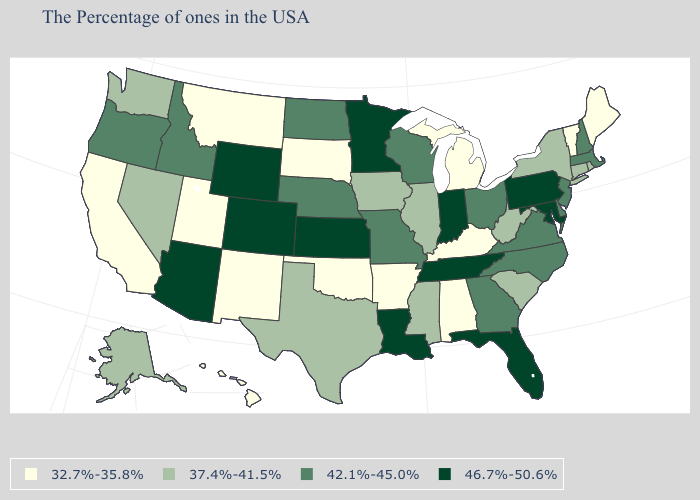What is the value of Iowa?
Answer briefly. 37.4%-41.5%. Name the states that have a value in the range 42.1%-45.0%?
Give a very brief answer. Massachusetts, New Hampshire, New Jersey, Delaware, Virginia, North Carolina, Ohio, Georgia, Wisconsin, Missouri, Nebraska, North Dakota, Idaho, Oregon. Name the states that have a value in the range 37.4%-41.5%?
Answer briefly. Rhode Island, Connecticut, New York, South Carolina, West Virginia, Illinois, Mississippi, Iowa, Texas, Nevada, Washington, Alaska. What is the value of Connecticut?
Give a very brief answer. 37.4%-41.5%. Name the states that have a value in the range 46.7%-50.6%?
Quick response, please. Maryland, Pennsylvania, Florida, Indiana, Tennessee, Louisiana, Minnesota, Kansas, Wyoming, Colorado, Arizona. Among the states that border Tennessee , does Virginia have the lowest value?
Keep it brief. No. Does Nevada have the highest value in the USA?
Give a very brief answer. No. What is the lowest value in the USA?
Concise answer only. 32.7%-35.8%. What is the highest value in the West ?
Short answer required. 46.7%-50.6%. Name the states that have a value in the range 32.7%-35.8%?
Keep it brief. Maine, Vermont, Michigan, Kentucky, Alabama, Arkansas, Oklahoma, South Dakota, New Mexico, Utah, Montana, California, Hawaii. Which states have the highest value in the USA?
Write a very short answer. Maryland, Pennsylvania, Florida, Indiana, Tennessee, Louisiana, Minnesota, Kansas, Wyoming, Colorado, Arizona. Does Hawaii have the lowest value in the USA?
Keep it brief. Yes. Name the states that have a value in the range 42.1%-45.0%?
Keep it brief. Massachusetts, New Hampshire, New Jersey, Delaware, Virginia, North Carolina, Ohio, Georgia, Wisconsin, Missouri, Nebraska, North Dakota, Idaho, Oregon. What is the highest value in the South ?
Concise answer only. 46.7%-50.6%. 